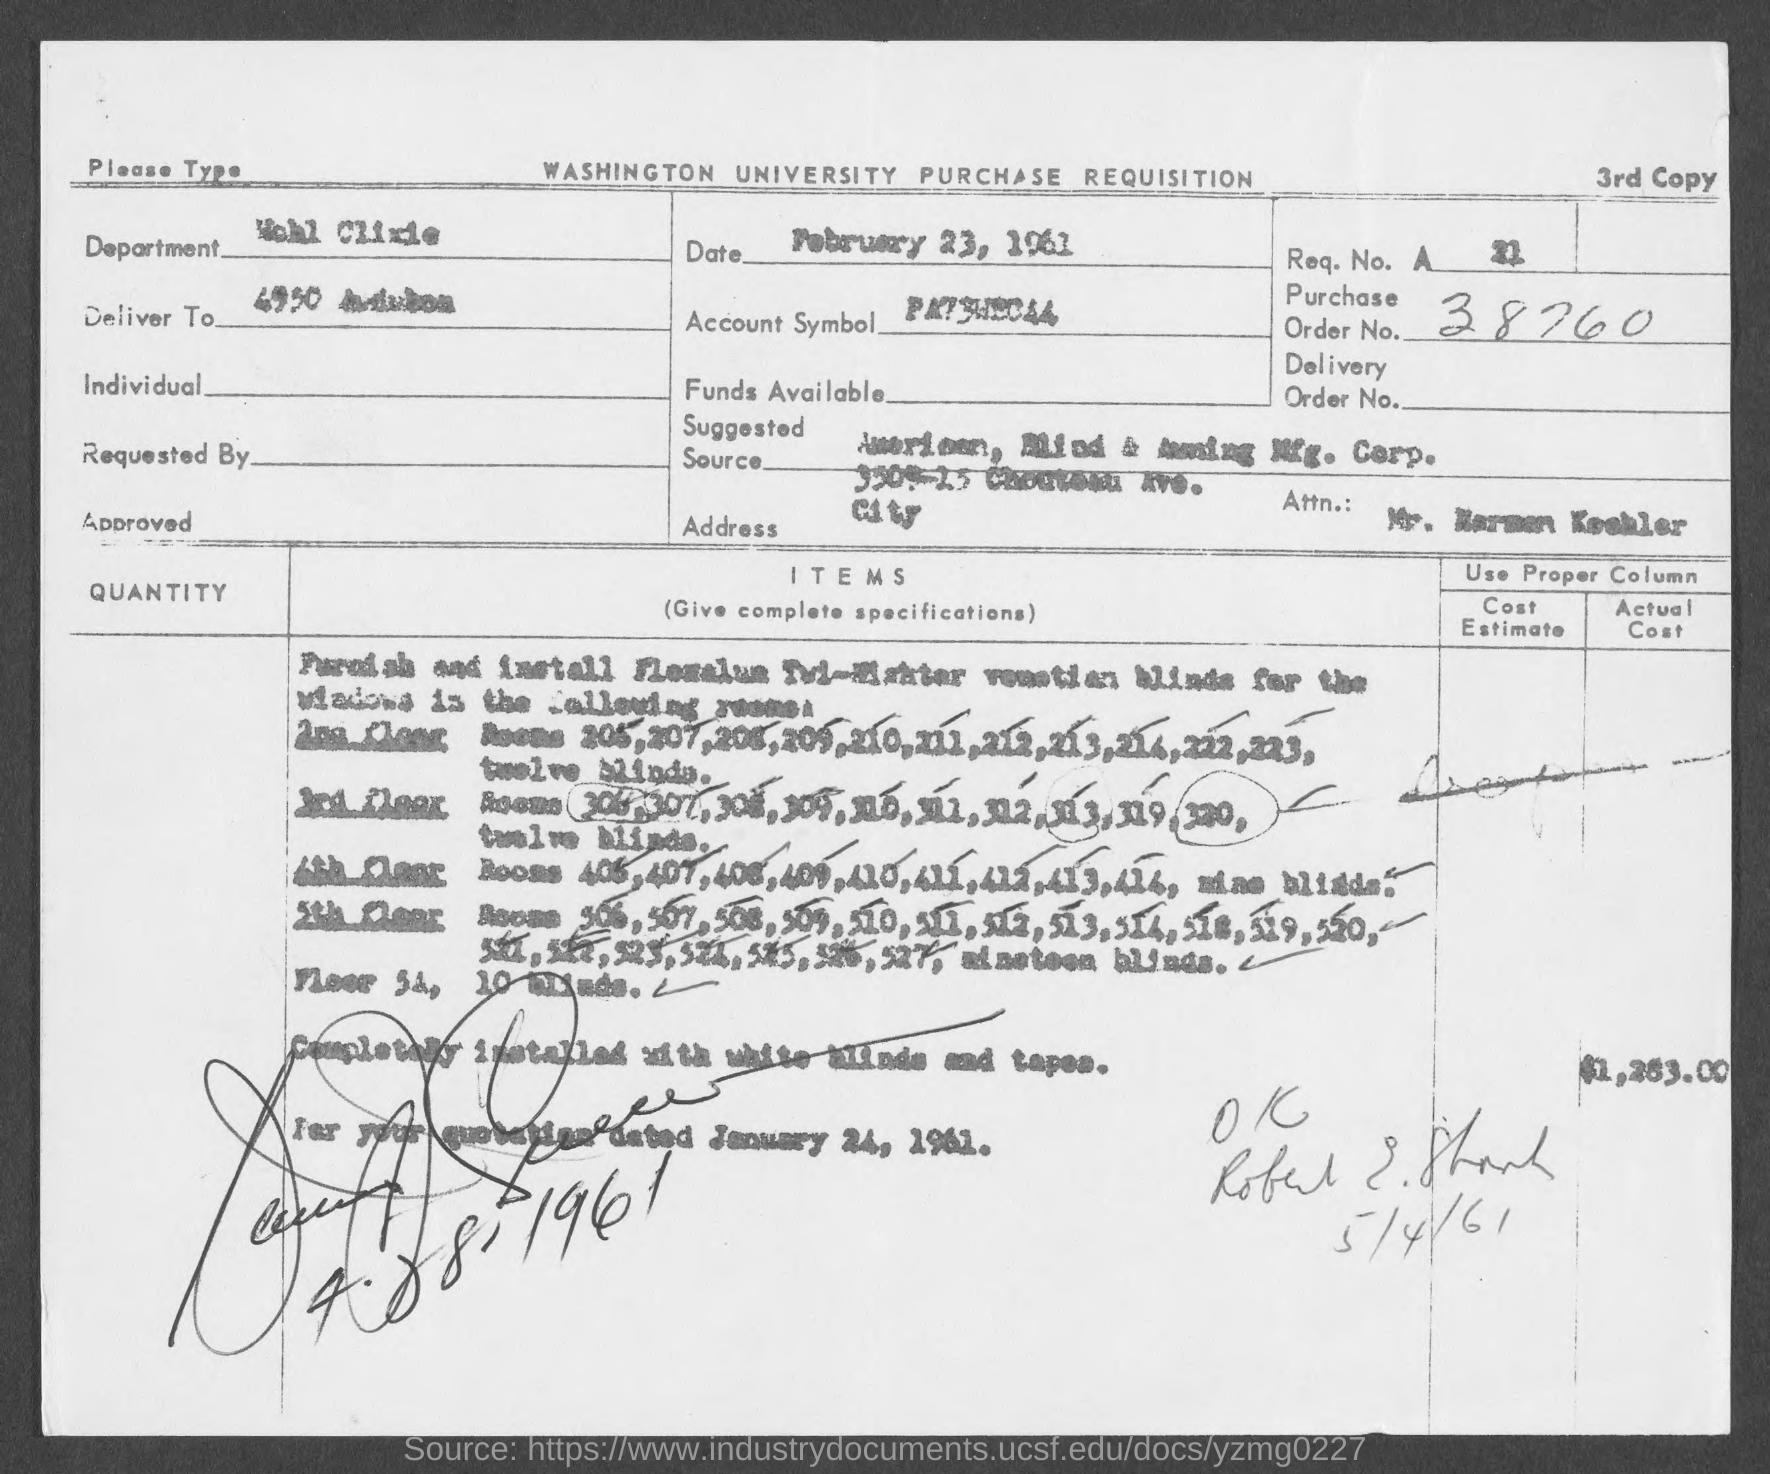What is the date on the document?
Your answer should be very brief. February 23, 1961. What is the Purchase Order No.?
Offer a very short reply. 38760. 